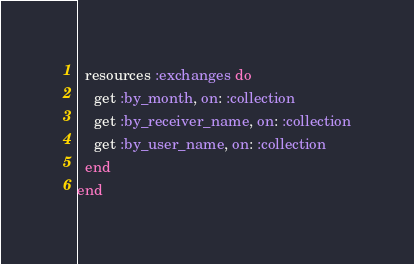Convert code to text. <code><loc_0><loc_0><loc_500><loc_500><_Ruby_>
  resources :exchanges do
    get :by_month, on: :collection
    get :by_receiver_name, on: :collection
    get :by_user_name, on: :collection
  end
end
</code> 